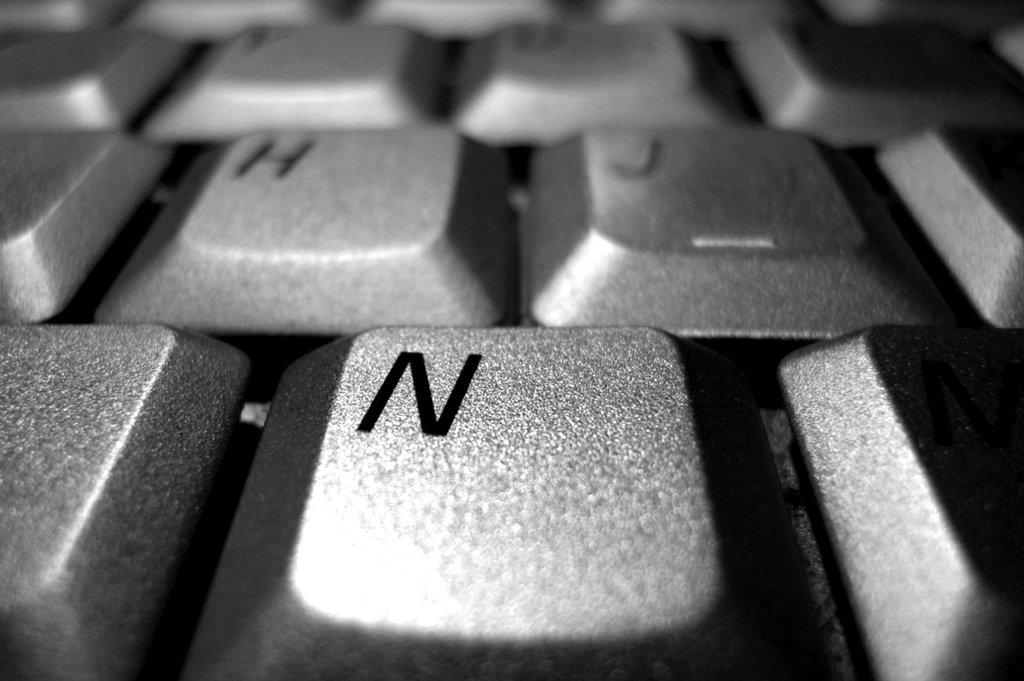<image>
Create a compact narrative representing the image presented. The N key of a computer keyboard is displayed in a huge close up. 